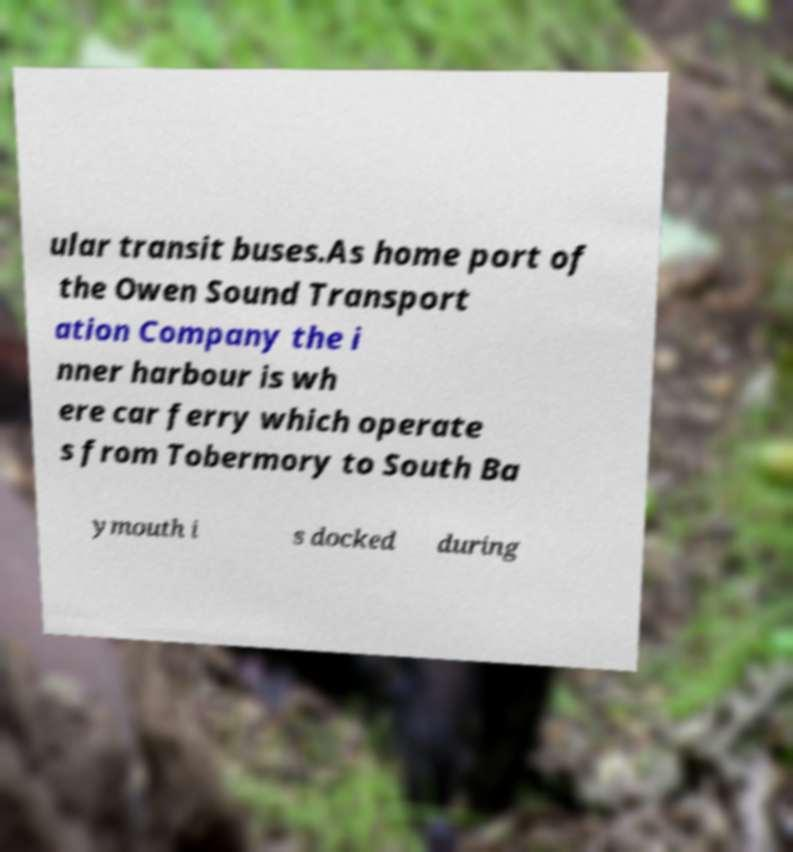Please read and relay the text visible in this image. What does it say? ular transit buses.As home port of the Owen Sound Transport ation Company the i nner harbour is wh ere car ferry which operate s from Tobermory to South Ba ymouth i s docked during 